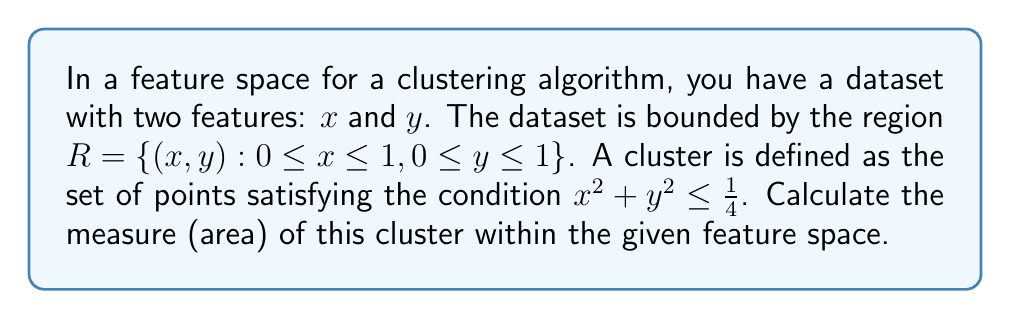Give your solution to this math problem. To solve this problem, we need to follow these steps:

1) The cluster is defined by the inequality $x^2 + y^2 \leq \frac{1}{4}$, which represents a circle with radius $r = \frac{1}{2}$ centered at the origin (0, 0).

2) However, the feature space is bounded by the unit square $R = \{(x, y) : 0 \leq x \leq 1, 0 \leq y \leq 1\}$. This means we're only interested in the part of the circle that lies within the first quadrant.

3) The area of a full circle is given by $A = \pi r^2$. In this case:

   $$A_{full} = \pi (\frac{1}{2})^2 = \frac{\pi}{4}$$

4) Since we're only interested in the first quadrant, we need to calculate a quarter of this area:

   $$A_{cluster} = \frac{1}{4} \cdot \frac{\pi}{4} = \frac{\pi}{16}$$

5) This gives us the measure (area) of the cluster within the given feature space.

[asy]
import geometry;

size(200);
draw((0,0)--(1,0)--(1,1)--(0,1)--cycle);
draw(arc((0,0),0.5,0,90));
label("R", (0.5,0.5));
label("Cluster", (0.25,0.25));
[/asy]
Answer: The measure (area) of the cluster within the given feature space is $\frac{\pi}{16}$ square units. 